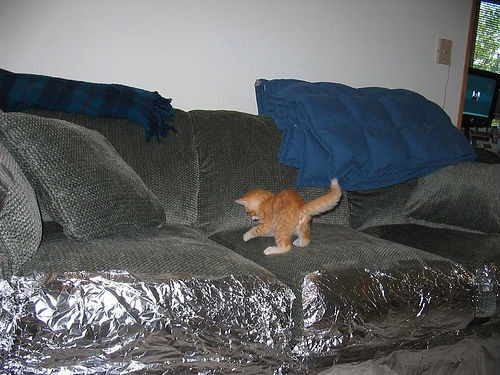Describe the objects in this image and their specific colors. I can see couch in black, gray, navy, and darkgray tones, cat in gray, tan, brown, and darkgray tones, and tv in gray, black, darkblue, and teal tones in this image. 